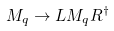Convert formula to latex. <formula><loc_0><loc_0><loc_500><loc_500>M _ { q } \rightarrow L M _ { q } R ^ { \dagger }</formula> 